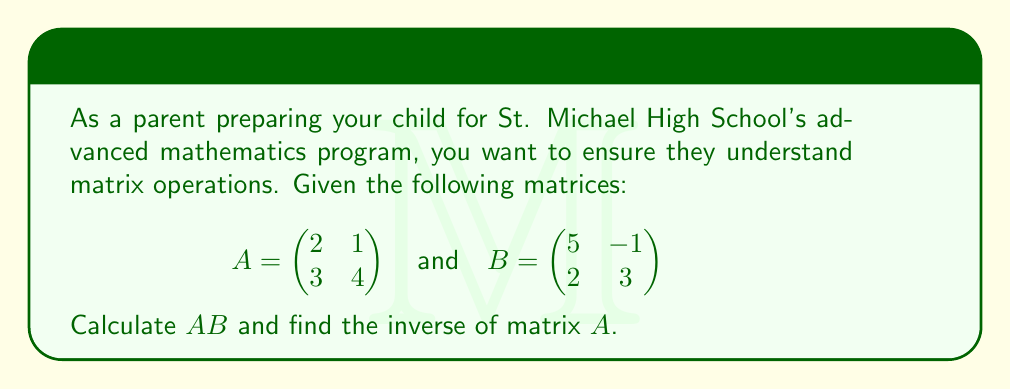Teach me how to tackle this problem. Let's approach this problem step by step:

1. Matrix multiplication $AB$:
To multiply two 2x2 matrices, we use the following formula:
$$AB = \begin{pmatrix} 
a_{11}b_{11} + a_{12}b_{21} & a_{11}b_{12} + a_{12}b_{22} \\
a_{21}b_{11} + a_{22}b_{21} & a_{21}b_{12} + a_{22}b_{22}
\end{pmatrix}$$

Calculating each element:
$$(AB)_{11} = (2)(5) + (1)(2) = 10 + 2 = 12$$
$$(AB)_{12} = (2)(-1) + (1)(3) = -2 + 3 = 1$$
$$(AB)_{21} = (3)(5) + (4)(2) = 15 + 8 = 23$$
$$(AB)_{22} = (3)(-1) + (4)(3) = -3 + 12 = 9$$

Therefore, $AB = \begin{pmatrix} 12 & 1 \\ 23 & 9 \end{pmatrix}$

2. Finding the inverse of matrix $A$:
To find the inverse of a 2x2 matrix, we use the following formula:

$$A^{-1} = \frac{1}{det(A)} \begin{pmatrix} a_{22} & -a_{12} \\ -a_{21} & a_{11} \end{pmatrix}$$

First, calculate the determinant of $A$:
$$det(A) = (2)(4) - (1)(3) = 8 - 3 = 5$$

Now, we can calculate $A^{-1}$:

$$A^{-1} = \frac{1}{5} \begin{pmatrix} 4 & -1 \\ -3 & 2 \end{pmatrix}$$

Simplifying:

$$A^{-1} = \begin{pmatrix} 4/5 & -1/5 \\ -3/5 & 2/5 \end{pmatrix}$$
Answer: $AB = \begin{pmatrix} 12 & 1 \\ 23 & 9 \end{pmatrix}$

$A^{-1} = \begin{pmatrix} 4/5 & -1/5 \\ -3/5 & 2/5 \end{pmatrix}$ 